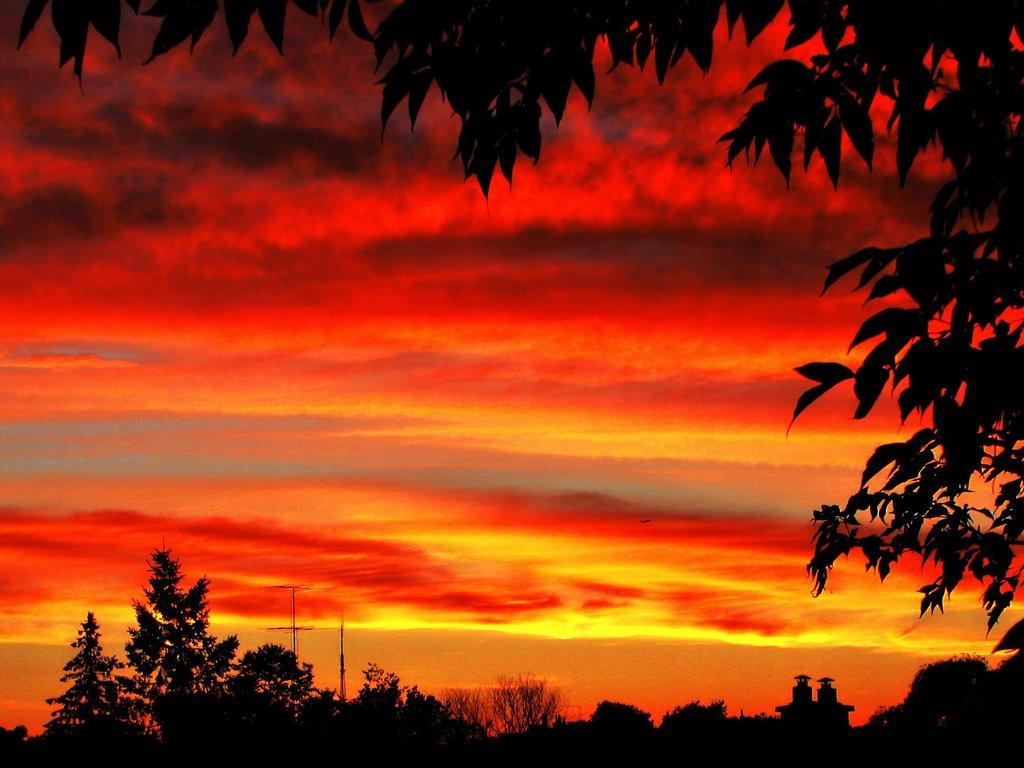What type of vegetation can be seen in the image? There are trees in the image. What part of the natural environment is visible in the image? The sky is visible in the image. How would you describe the sky in the image? The sky appears to be cloudy in the image. How would you describe the overall lighting in the image? The image appears to be a bit dark. Is there a fireman putting out a fire on the wrist of a person in the image? There is no fireman or any fire-related activity present in the image. 